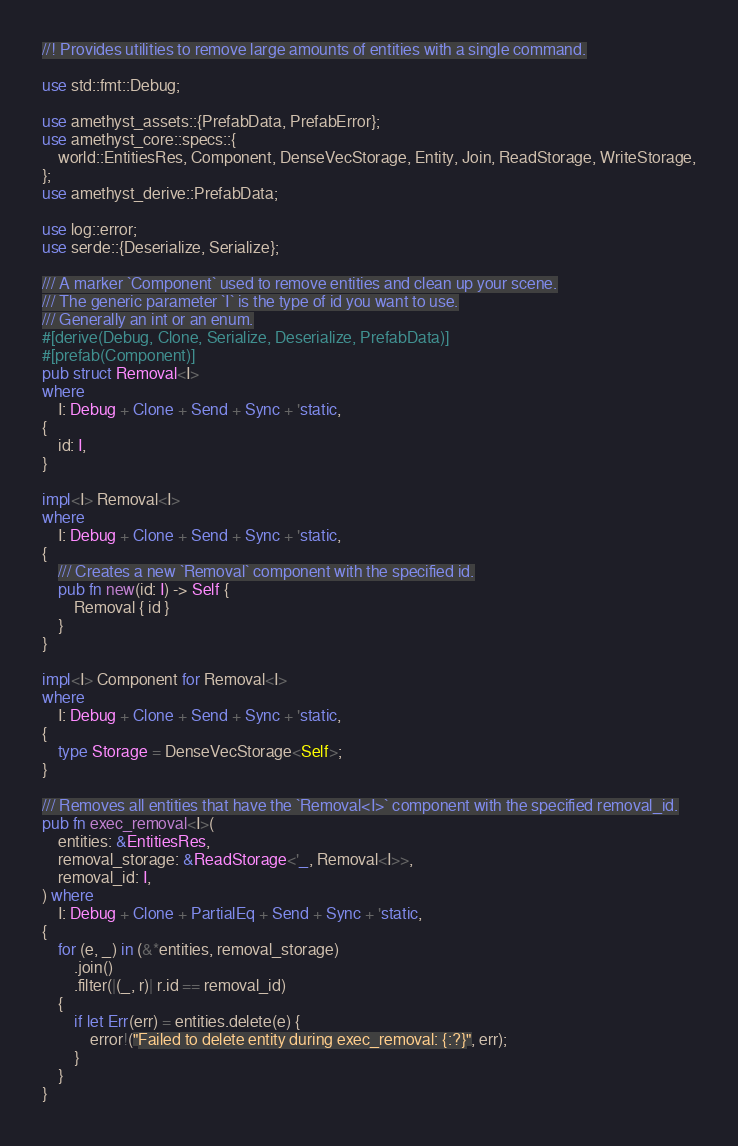<code> <loc_0><loc_0><loc_500><loc_500><_Rust_>//! Provides utilities to remove large amounts of entities with a single command.

use std::fmt::Debug;

use amethyst_assets::{PrefabData, PrefabError};
use amethyst_core::specs::{
    world::EntitiesRes, Component, DenseVecStorage, Entity, Join, ReadStorage, WriteStorage,
};
use amethyst_derive::PrefabData;

use log::error;
use serde::{Deserialize, Serialize};

/// A marker `Component` used to remove entities and clean up your scene.
/// The generic parameter `I` is the type of id you want to use.
/// Generally an int or an enum.
#[derive(Debug, Clone, Serialize, Deserialize, PrefabData)]
#[prefab(Component)]
pub struct Removal<I>
where
    I: Debug + Clone + Send + Sync + 'static,
{
    id: I,
}

impl<I> Removal<I>
where
    I: Debug + Clone + Send + Sync + 'static,
{
    /// Creates a new `Removal` component with the specified id.
    pub fn new(id: I) -> Self {
        Removal { id }
    }
}

impl<I> Component for Removal<I>
where
    I: Debug + Clone + Send + Sync + 'static,
{
    type Storage = DenseVecStorage<Self>;
}

/// Removes all entities that have the `Removal<I>` component with the specified removal_id.
pub fn exec_removal<I>(
    entities: &EntitiesRes,
    removal_storage: &ReadStorage<'_, Removal<I>>,
    removal_id: I,
) where
    I: Debug + Clone + PartialEq + Send + Sync + 'static,
{
    for (e, _) in (&*entities, removal_storage)
        .join()
        .filter(|(_, r)| r.id == removal_id)
    {
        if let Err(err) = entities.delete(e) {
            error!("Failed to delete entity during exec_removal: {:?}", err);
        }
    }
}
</code> 